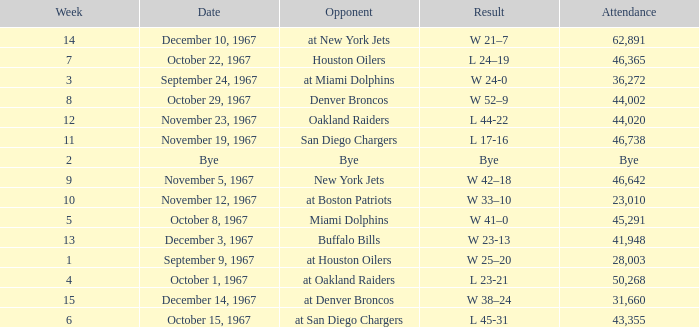What was the date of the game after week 5 against the Houston Oilers? October 22, 1967. 